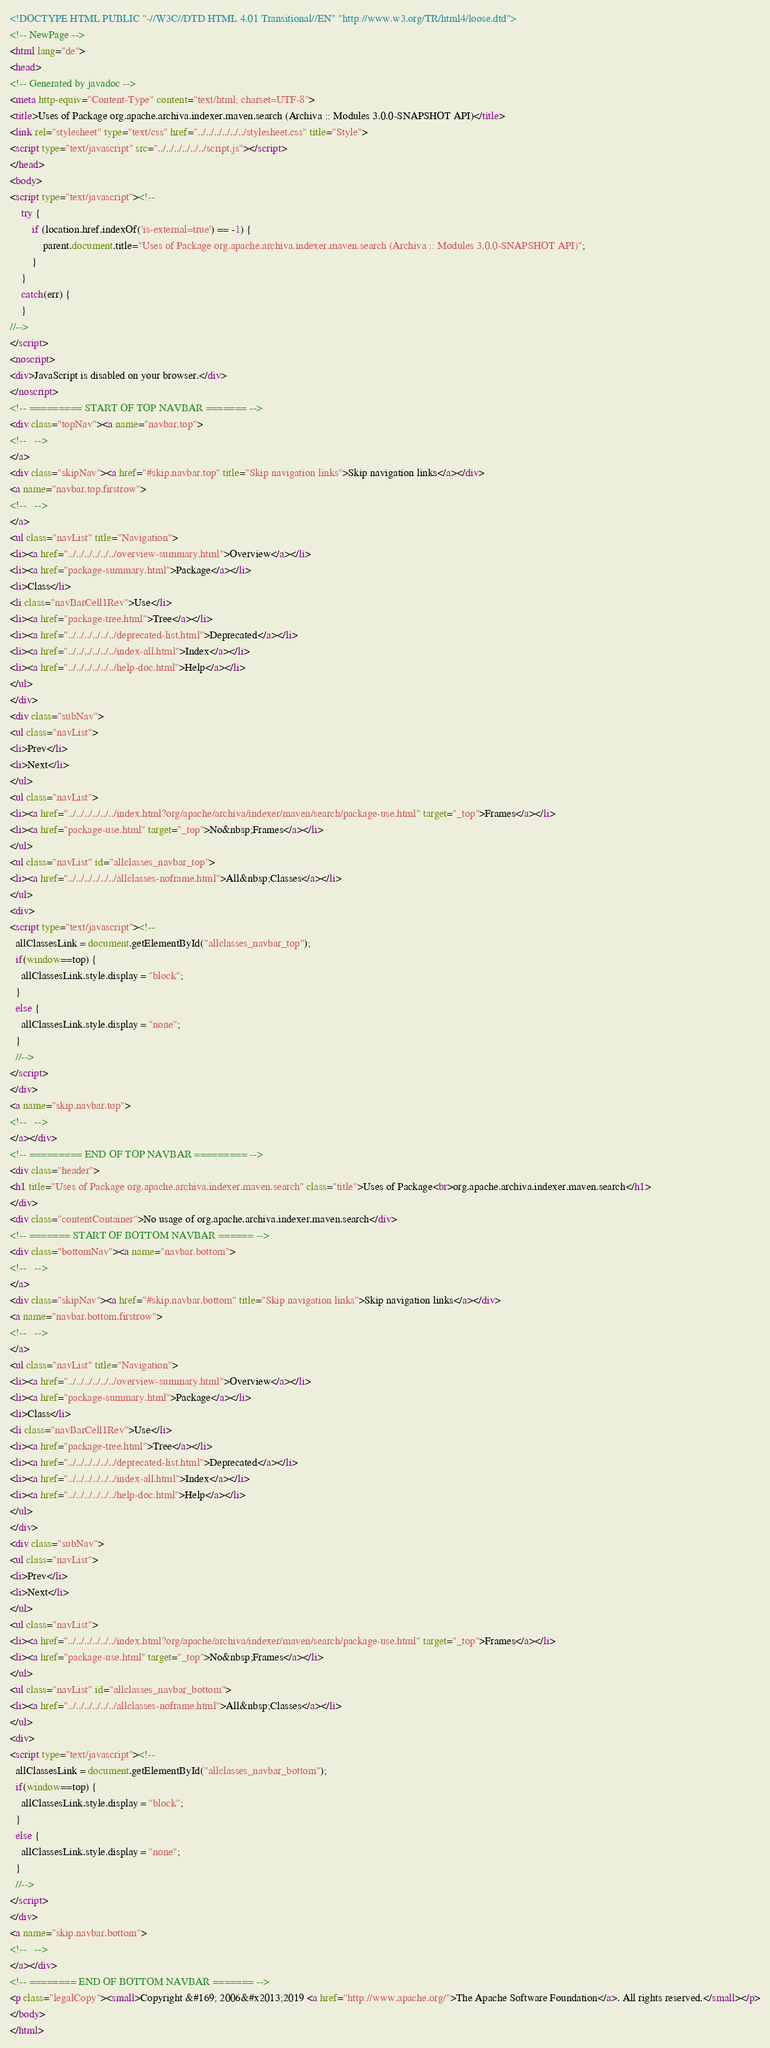<code> <loc_0><loc_0><loc_500><loc_500><_HTML_><!DOCTYPE HTML PUBLIC "-//W3C//DTD HTML 4.01 Transitional//EN" "http://www.w3.org/TR/html4/loose.dtd">
<!-- NewPage -->
<html lang="de">
<head>
<!-- Generated by javadoc -->
<meta http-equiv="Content-Type" content="text/html; charset=UTF-8">
<title>Uses of Package org.apache.archiva.indexer.maven.search (Archiva :: Modules 3.0.0-SNAPSHOT API)</title>
<link rel="stylesheet" type="text/css" href="../../../../../../stylesheet.css" title="Style">
<script type="text/javascript" src="../../../../../../script.js"></script>
</head>
<body>
<script type="text/javascript"><!--
    try {
        if (location.href.indexOf('is-external=true') == -1) {
            parent.document.title="Uses of Package org.apache.archiva.indexer.maven.search (Archiva :: Modules 3.0.0-SNAPSHOT API)";
        }
    }
    catch(err) {
    }
//-->
</script>
<noscript>
<div>JavaScript is disabled on your browser.</div>
</noscript>
<!-- ========= START OF TOP NAVBAR ======= -->
<div class="topNav"><a name="navbar.top">
<!--   -->
</a>
<div class="skipNav"><a href="#skip.navbar.top" title="Skip navigation links">Skip navigation links</a></div>
<a name="navbar.top.firstrow">
<!--   -->
</a>
<ul class="navList" title="Navigation">
<li><a href="../../../../../../overview-summary.html">Overview</a></li>
<li><a href="package-summary.html">Package</a></li>
<li>Class</li>
<li class="navBarCell1Rev">Use</li>
<li><a href="package-tree.html">Tree</a></li>
<li><a href="../../../../../../deprecated-list.html">Deprecated</a></li>
<li><a href="../../../../../../index-all.html">Index</a></li>
<li><a href="../../../../../../help-doc.html">Help</a></li>
</ul>
</div>
<div class="subNav">
<ul class="navList">
<li>Prev</li>
<li>Next</li>
</ul>
<ul class="navList">
<li><a href="../../../../../../index.html?org/apache/archiva/indexer/maven/search/package-use.html" target="_top">Frames</a></li>
<li><a href="package-use.html" target="_top">No&nbsp;Frames</a></li>
</ul>
<ul class="navList" id="allclasses_navbar_top">
<li><a href="../../../../../../allclasses-noframe.html">All&nbsp;Classes</a></li>
</ul>
<div>
<script type="text/javascript"><!--
  allClassesLink = document.getElementById("allclasses_navbar_top");
  if(window==top) {
    allClassesLink.style.display = "block";
  }
  else {
    allClassesLink.style.display = "none";
  }
  //-->
</script>
</div>
<a name="skip.navbar.top">
<!--   -->
</a></div>
<!-- ========= END OF TOP NAVBAR ========= -->
<div class="header">
<h1 title="Uses of Package org.apache.archiva.indexer.maven.search" class="title">Uses of Package<br>org.apache.archiva.indexer.maven.search</h1>
</div>
<div class="contentContainer">No usage of org.apache.archiva.indexer.maven.search</div>
<!-- ======= START OF BOTTOM NAVBAR ====== -->
<div class="bottomNav"><a name="navbar.bottom">
<!--   -->
</a>
<div class="skipNav"><a href="#skip.navbar.bottom" title="Skip navigation links">Skip navigation links</a></div>
<a name="navbar.bottom.firstrow">
<!--   -->
</a>
<ul class="navList" title="Navigation">
<li><a href="../../../../../../overview-summary.html">Overview</a></li>
<li><a href="package-summary.html">Package</a></li>
<li>Class</li>
<li class="navBarCell1Rev">Use</li>
<li><a href="package-tree.html">Tree</a></li>
<li><a href="../../../../../../deprecated-list.html">Deprecated</a></li>
<li><a href="../../../../../../index-all.html">Index</a></li>
<li><a href="../../../../../../help-doc.html">Help</a></li>
</ul>
</div>
<div class="subNav">
<ul class="navList">
<li>Prev</li>
<li>Next</li>
</ul>
<ul class="navList">
<li><a href="../../../../../../index.html?org/apache/archiva/indexer/maven/search/package-use.html" target="_top">Frames</a></li>
<li><a href="package-use.html" target="_top">No&nbsp;Frames</a></li>
</ul>
<ul class="navList" id="allclasses_navbar_bottom">
<li><a href="../../../../../../allclasses-noframe.html">All&nbsp;Classes</a></li>
</ul>
<div>
<script type="text/javascript"><!--
  allClassesLink = document.getElementById("allclasses_navbar_bottom");
  if(window==top) {
    allClassesLink.style.display = "block";
  }
  else {
    allClassesLink.style.display = "none";
  }
  //-->
</script>
</div>
<a name="skip.navbar.bottom">
<!--   -->
</a></div>
<!-- ======== END OF BOTTOM NAVBAR ======= -->
<p class="legalCopy"><small>Copyright &#169; 2006&#x2013;2019 <a href="http://www.apache.org/">The Apache Software Foundation</a>. All rights reserved.</small></p>
</body>
</html></code> 